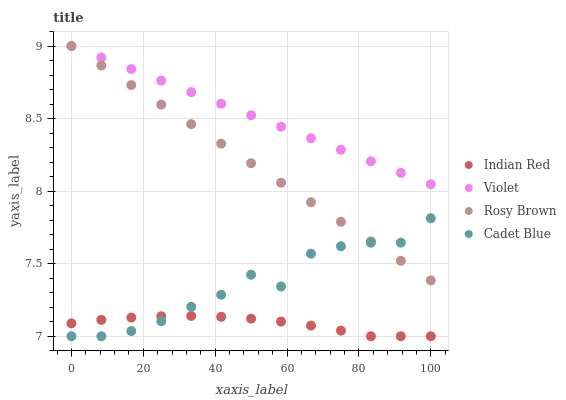Does Indian Red have the minimum area under the curve?
Answer yes or no. Yes. Does Violet have the maximum area under the curve?
Answer yes or no. Yes. Does Rosy Brown have the minimum area under the curve?
Answer yes or no. No. Does Rosy Brown have the maximum area under the curve?
Answer yes or no. No. Is Violet the smoothest?
Answer yes or no. Yes. Is Cadet Blue the roughest?
Answer yes or no. Yes. Is Rosy Brown the smoothest?
Answer yes or no. No. Is Rosy Brown the roughest?
Answer yes or no. No. Does Cadet Blue have the lowest value?
Answer yes or no. Yes. Does Rosy Brown have the lowest value?
Answer yes or no. No. Does Violet have the highest value?
Answer yes or no. Yes. Does Indian Red have the highest value?
Answer yes or no. No. Is Cadet Blue less than Violet?
Answer yes or no. Yes. Is Violet greater than Cadet Blue?
Answer yes or no. Yes. Does Cadet Blue intersect Indian Red?
Answer yes or no. Yes. Is Cadet Blue less than Indian Red?
Answer yes or no. No. Is Cadet Blue greater than Indian Red?
Answer yes or no. No. Does Cadet Blue intersect Violet?
Answer yes or no. No. 